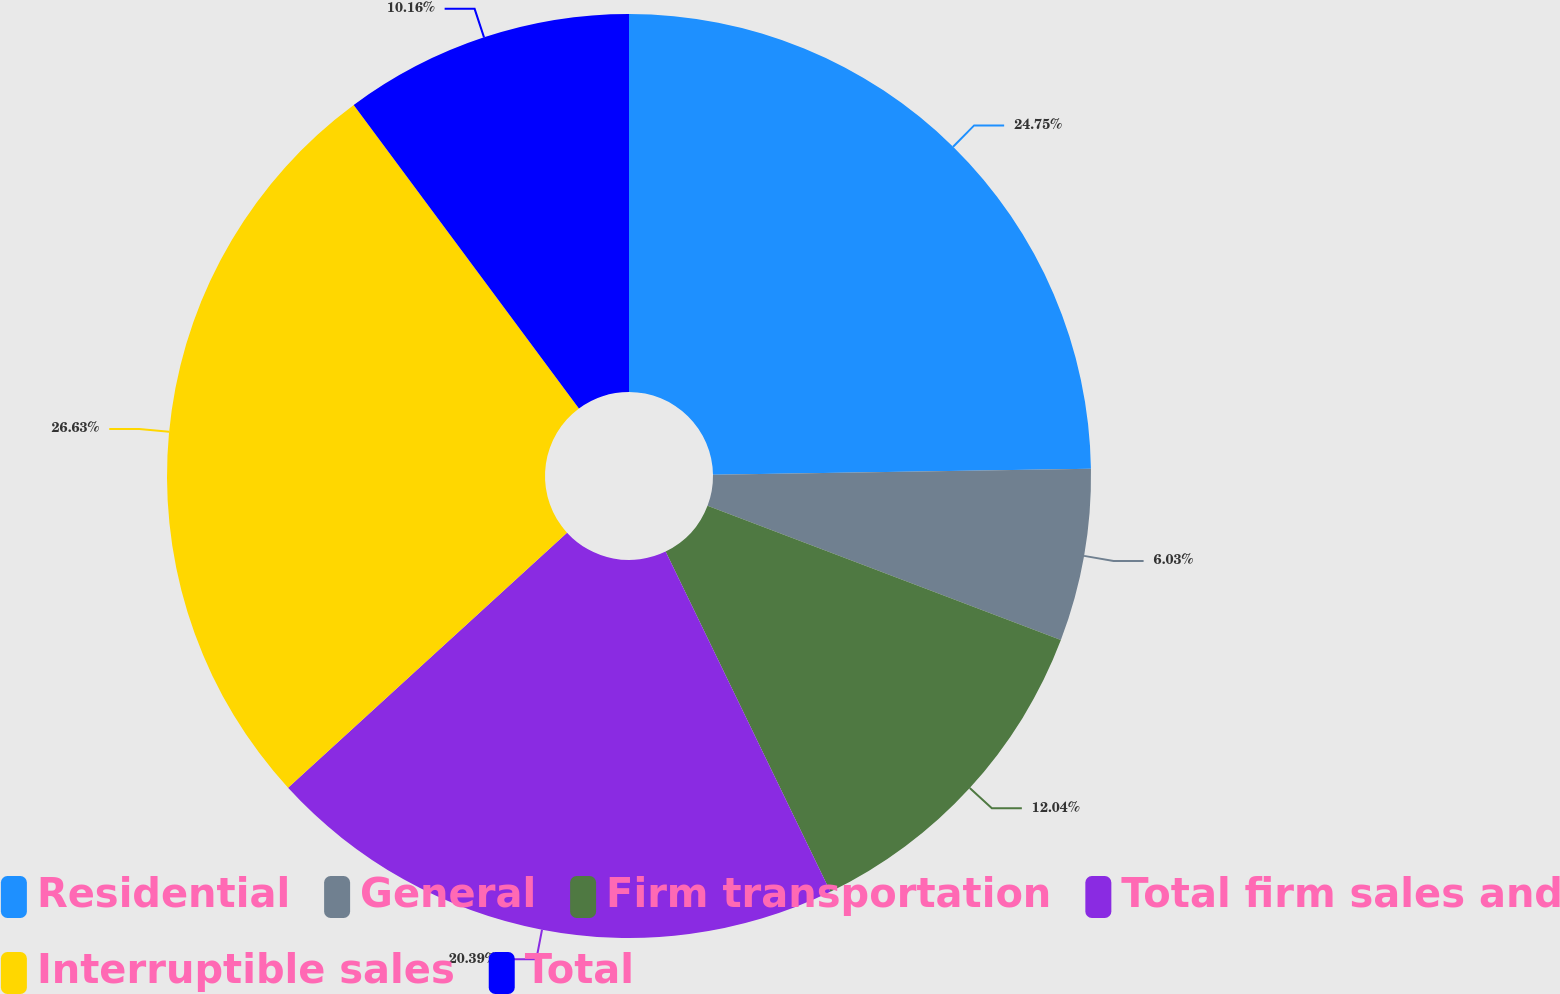<chart> <loc_0><loc_0><loc_500><loc_500><pie_chart><fcel>Residential<fcel>General<fcel>Firm transportation<fcel>Total firm sales and<fcel>Interruptible sales<fcel>Total<nl><fcel>24.75%<fcel>6.03%<fcel>12.04%<fcel>20.39%<fcel>26.63%<fcel>10.16%<nl></chart> 